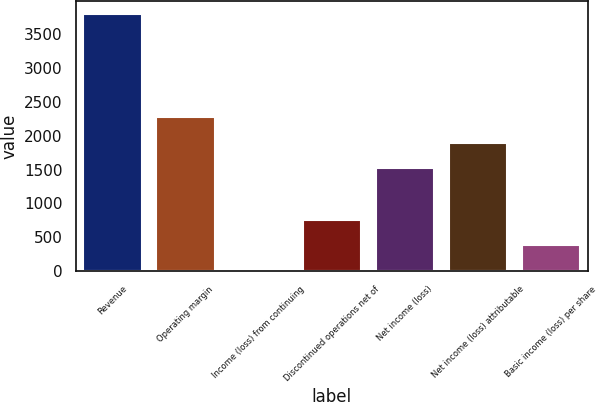Convert chart. <chart><loc_0><loc_0><loc_500><loc_500><bar_chart><fcel>Revenue<fcel>Operating margin<fcel>Income (loss) from continuing<fcel>Discontinued operations net of<fcel>Net income (loss)<fcel>Net income (loss) attributable<fcel>Basic income (loss) per share<nl><fcel>3800<fcel>2280.11<fcel>0.23<fcel>760.19<fcel>1520.15<fcel>1900.13<fcel>380.21<nl></chart> 